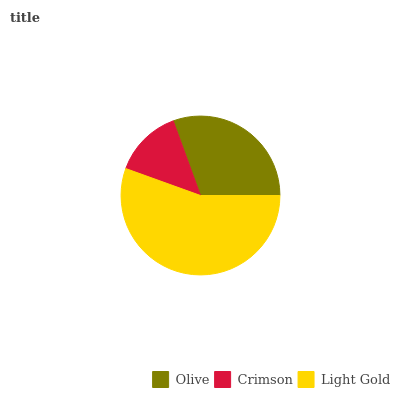Is Crimson the minimum?
Answer yes or no. Yes. Is Light Gold the maximum?
Answer yes or no. Yes. Is Light Gold the minimum?
Answer yes or no. No. Is Crimson the maximum?
Answer yes or no. No. Is Light Gold greater than Crimson?
Answer yes or no. Yes. Is Crimson less than Light Gold?
Answer yes or no. Yes. Is Crimson greater than Light Gold?
Answer yes or no. No. Is Light Gold less than Crimson?
Answer yes or no. No. Is Olive the high median?
Answer yes or no. Yes. Is Olive the low median?
Answer yes or no. Yes. Is Crimson the high median?
Answer yes or no. No. Is Light Gold the low median?
Answer yes or no. No. 